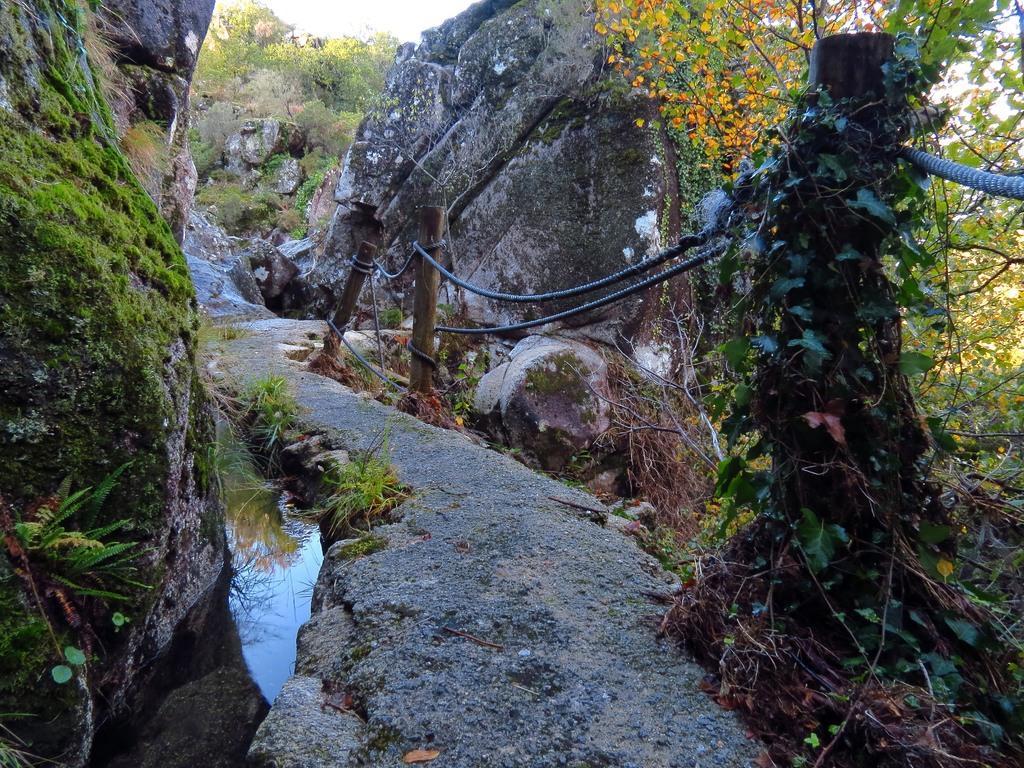Please provide a concise description of this image. In this image I can see the road, the water, few wooden poles and few ropes tied to the wooden poles. I can see huge rocks on both sides of the road, few trees, few flowers which are orange in color and the sky in the background. 